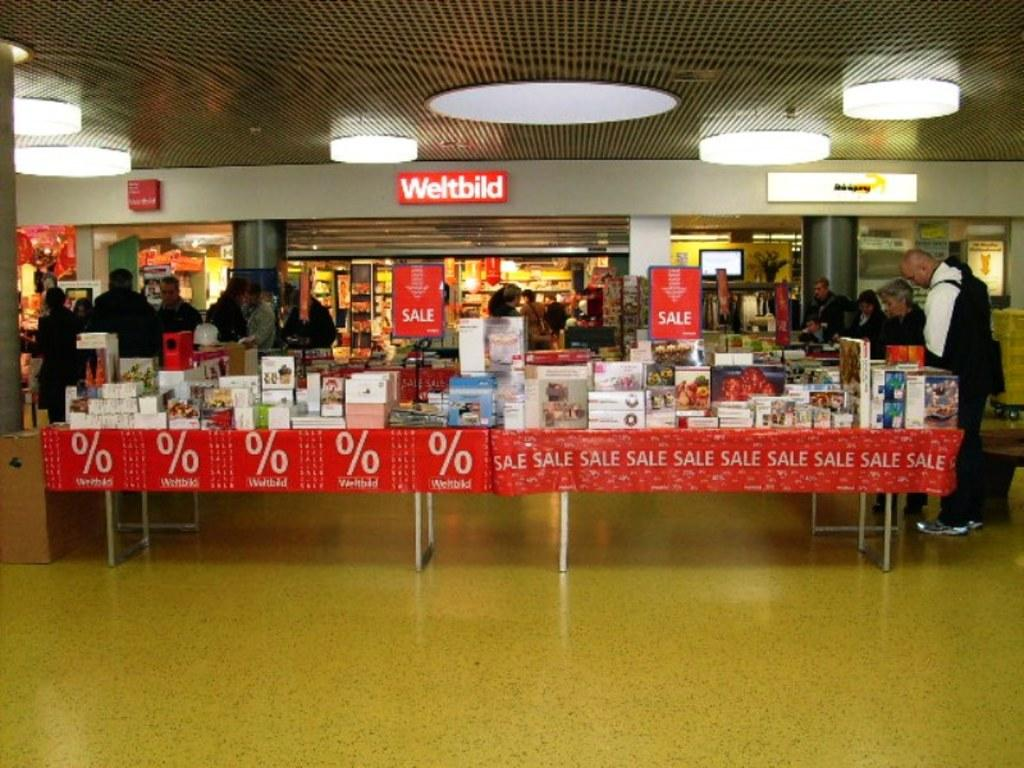Provide a one-sentence caption for the provided image. Booths covered in items are set up in front o the Weltbild store. 